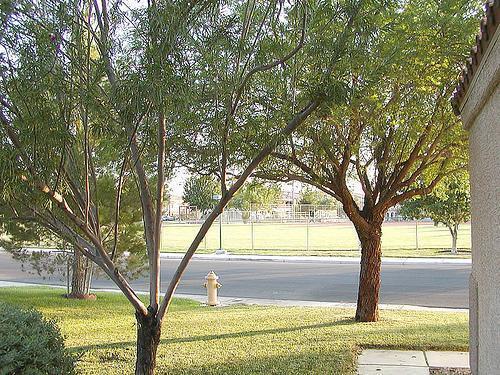How many people are there?
Give a very brief answer. 0. 